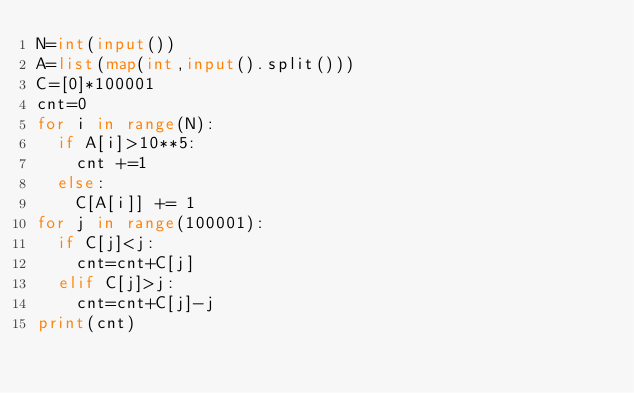Convert code to text. <code><loc_0><loc_0><loc_500><loc_500><_Python_>N=int(input())
A=list(map(int,input().split()))
C=[0]*100001
cnt=0
for i in range(N):
  if A[i]>10**5:
    cnt +=1
  else:
    C[A[i]] += 1
for j in range(100001):
  if C[j]<j:
    cnt=cnt+C[j]
  elif C[j]>j:
    cnt=cnt+C[j]-j
print(cnt)</code> 